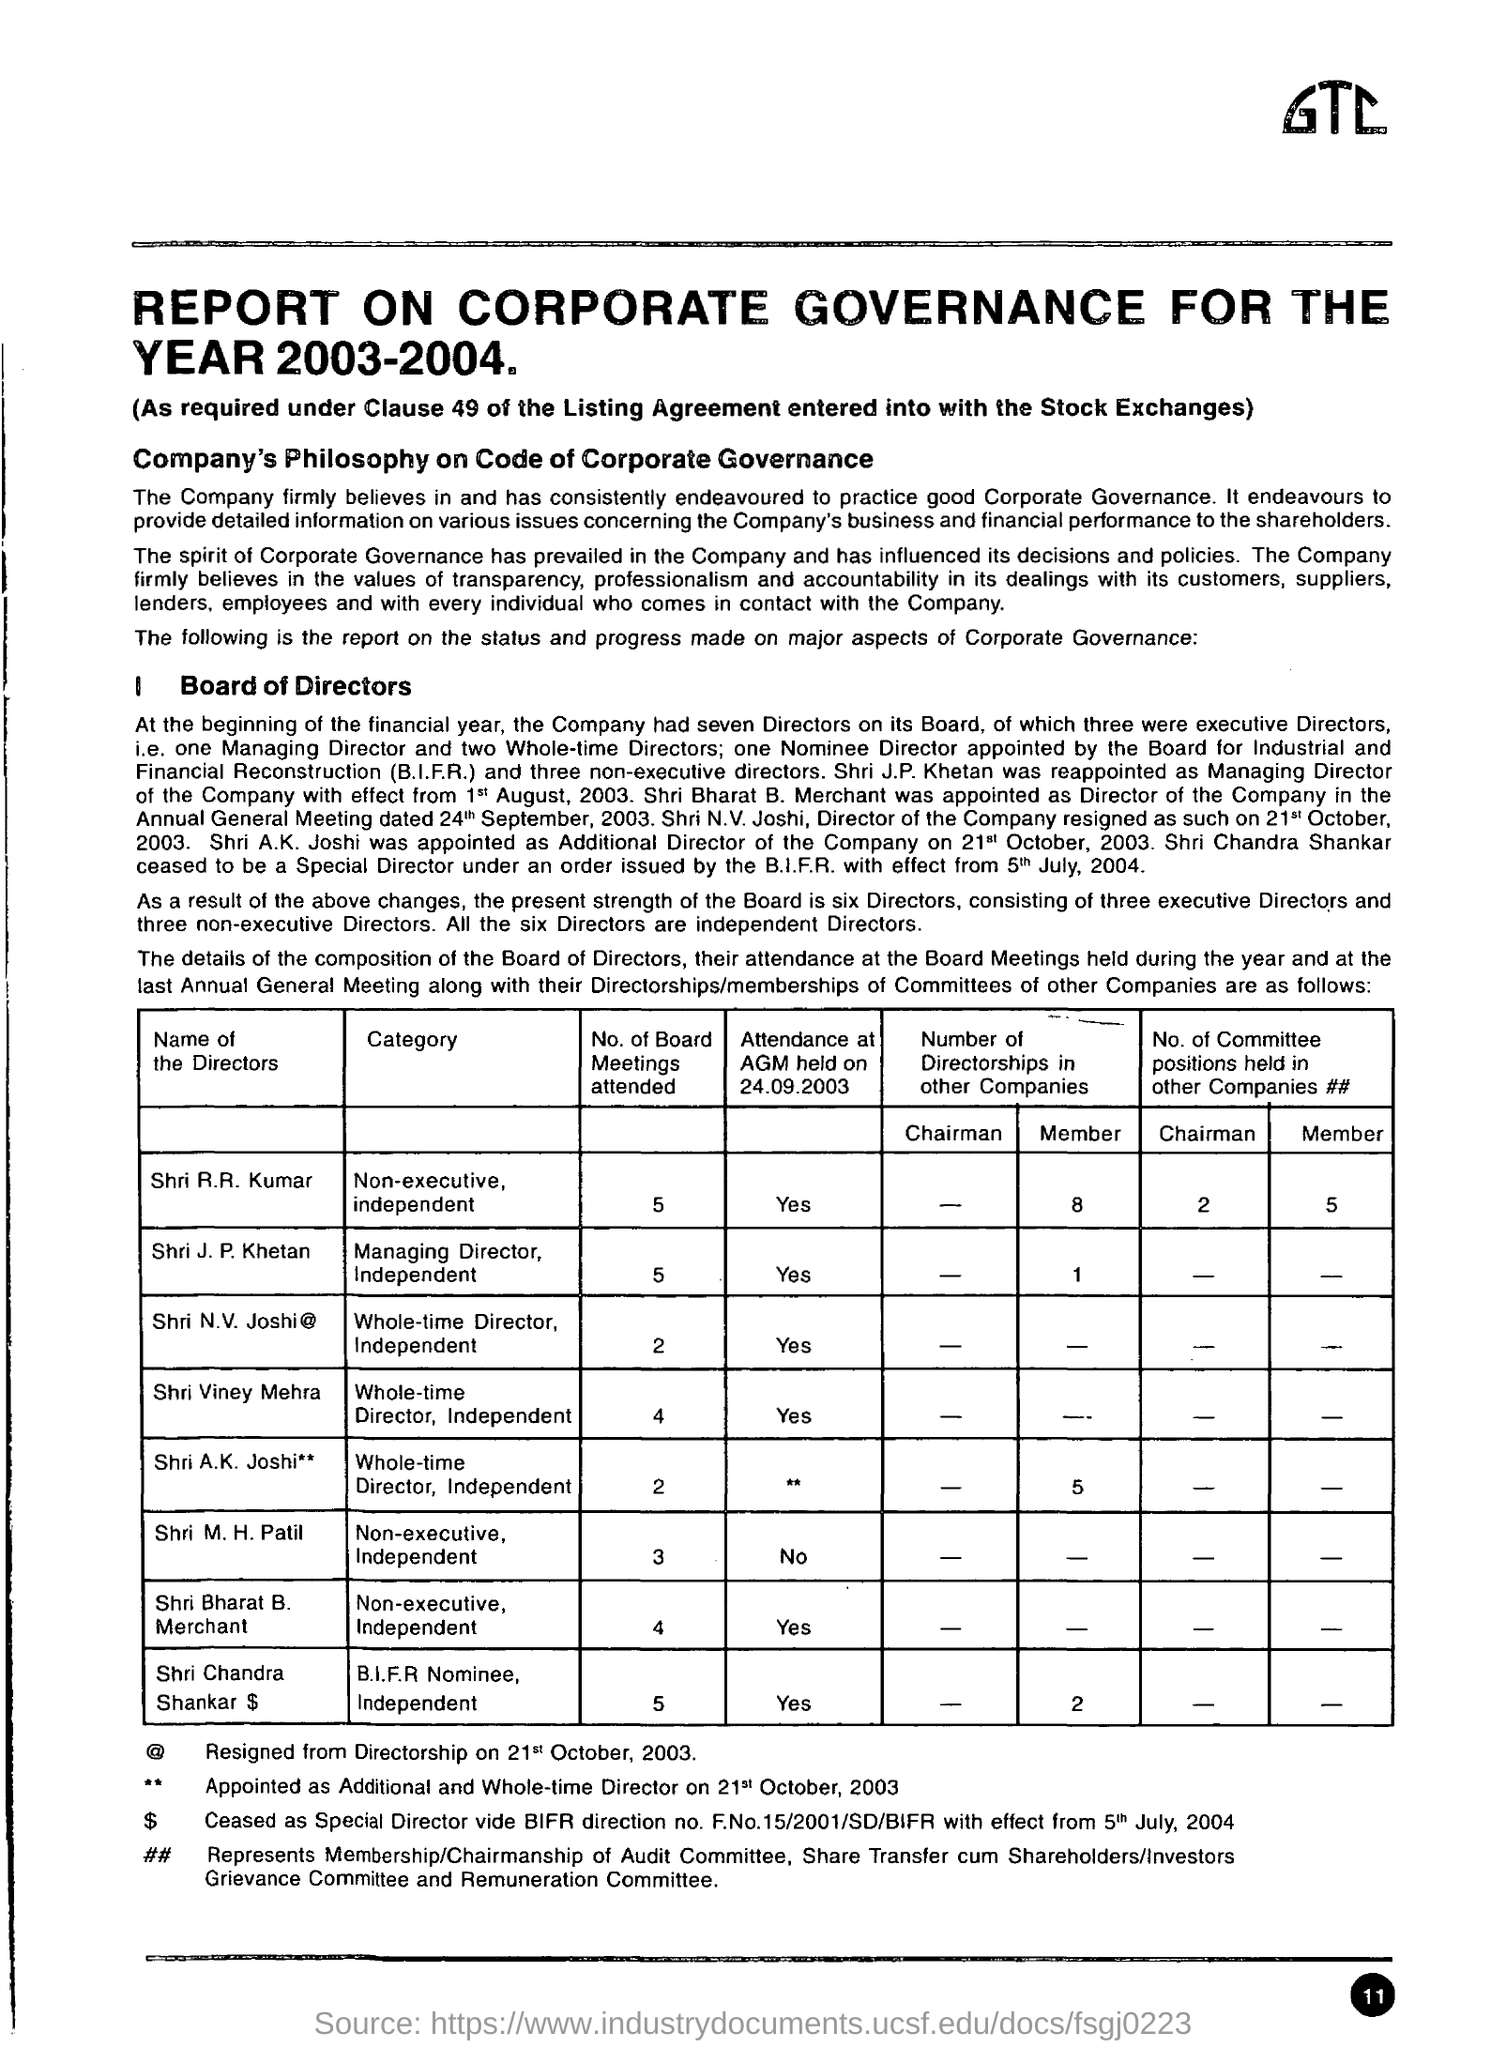What can you tell me about the attendance of these directors at board meetings? The attendance of directors at board meetings varies. For example, Shri R.R. Kumar and Shri J.P. Khetan attended all five board meetings, indicating strong participation. Shri N.V. Joshi attended two meetings, and Shri Viney Mehra attended four. Director attendance can be an indicator of their engagement and contribution to company governance. 